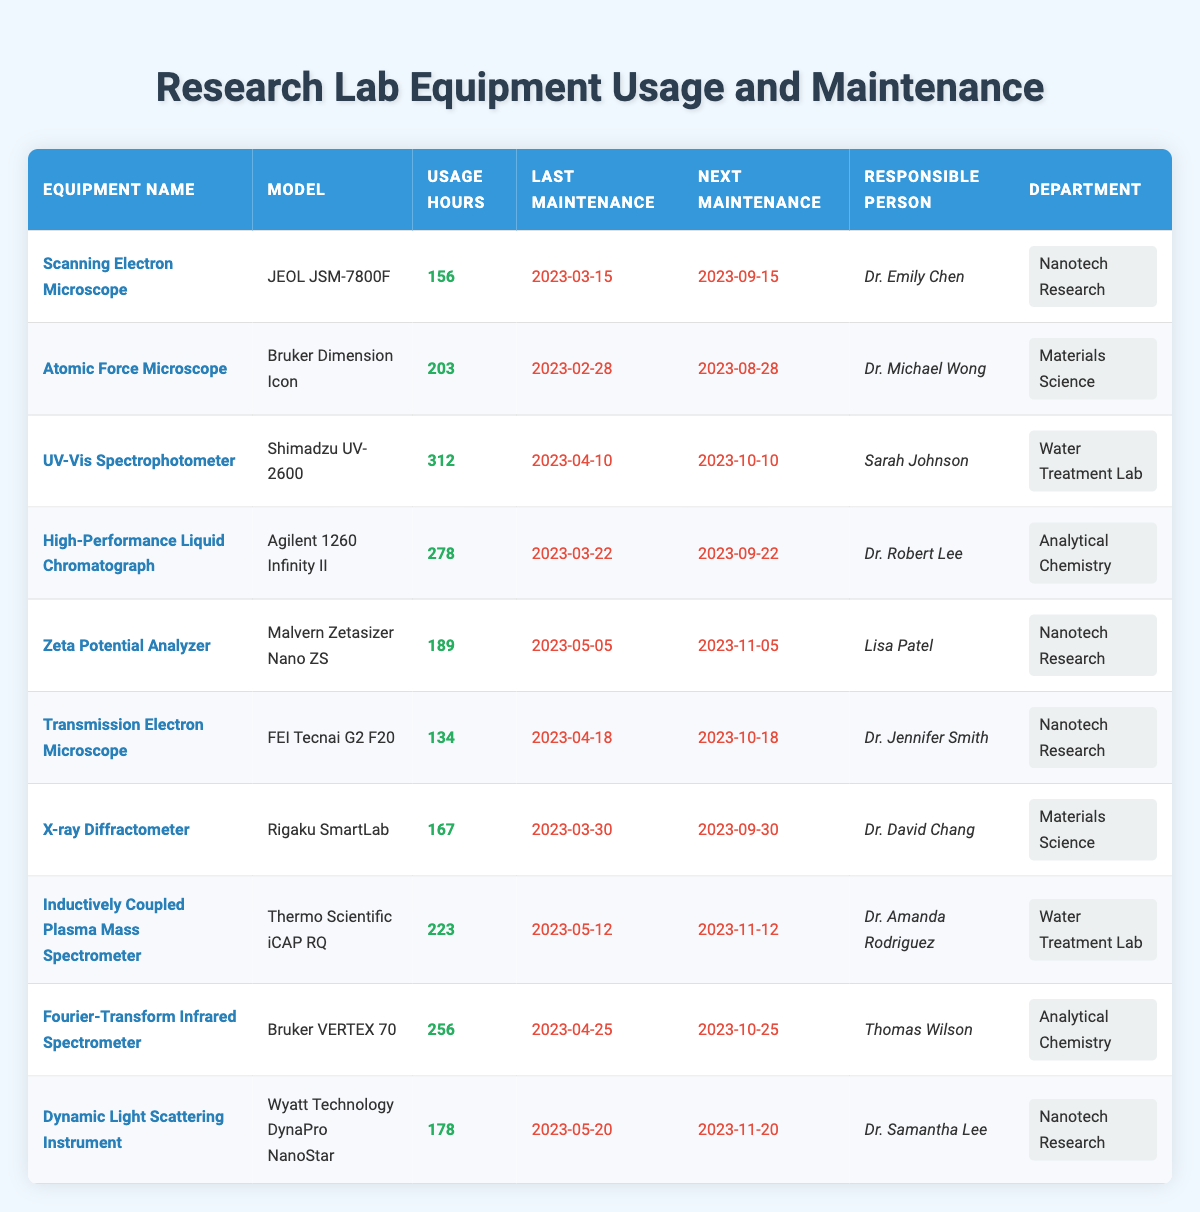What is the model of the Scanning Electron Microscope? The table lists the equipment name "Scanning Electron Microscope" in the first column. Cross-referencing this with the model column, it shows that the model is "JEOL JSM-7800F".
Answer: JEOL JSM-7800F Who is responsible for maintaining the UV-Vis Spectrophotometer? By looking at the row for the "UV-Vis Spectrophotometer", we see that the person responsible for its maintenance is "Sarah Johnson".
Answer: Sarah Johnson How many usage hours does the Inductively Coupled Plasma Mass Spectrometer have? In the row for the "Inductively Coupled Plasma Mass Spectrometer", the usage hours are listed directly as 223.
Answer: 223 What is the total usage hours of all equipment in the Nanotech Research department? Summing the usage hours for the equipment in the "Nanotech Research" department: 156 (Scanning Electron Microscope) + 189 (Zeta Potential Analyzer) + 134 (Transmission Electron Microscope) + 178 (Dynamic Light Scattering Instrument) = 657.
Answer: 657 Is the next maintenance date for the Atomic Force Microscope before the next maintenance date for the High-Performance Liquid Chromatograph? The next maintenance date for the Atomic Force Microscope is 2023-08-28 and for the High-Performance Liquid Chromatograph is 2023-09-22. Since 2023-08-28 is before 2023-09-22, the statement is true.
Answer: Yes Which equipment has the highest usage hours, and what is that value? By analyzing the usage hours for all equipment in the table, the UV-Vis Spectrophotometer shows the highest value at 312 usage hours.
Answer: 312 What is the average usage hours for the equipment in the Water Treatment Lab? The usage hours for the Water Treatment Lab equipment are: 312 (UV-Vis Spectrophotometer) and 223 (Inductively Coupled Plasma Mass Spectrometer), totaling 535 hours. To find the average, we divide this by the number of items (2): 535 / 2 = 267.5.
Answer: 267.5 Is the last maintenance date for the X-ray Diffractometer after the last maintenance date for the Scanning Electron Microscope? The last maintenance date for the X-ray Diffractometer is 2023-03-30, while for the Scanning Electron Microscope it is 2023-03-15. Since 2023-03-30 is after 2023-03-15, the statement is true.
Answer: Yes 